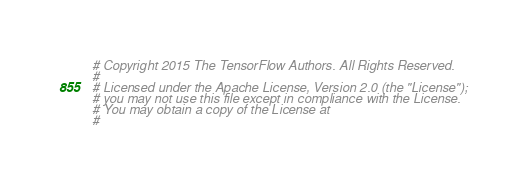Convert code to text. <code><loc_0><loc_0><loc_500><loc_500><_Python_># Copyright 2015 The TensorFlow Authors. All Rights Reserved.
#
# Licensed under the Apache License, Version 2.0 (the "License");
# you may not use this file except in compliance with the License.
# You may obtain a copy of the License at
#</code> 